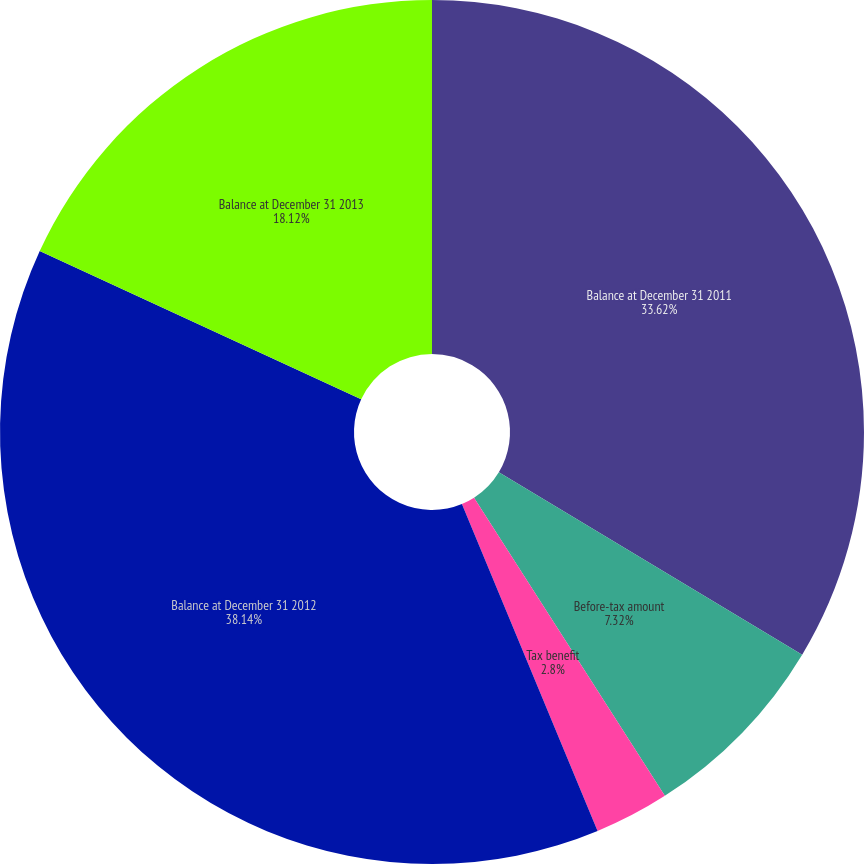Convert chart to OTSL. <chart><loc_0><loc_0><loc_500><loc_500><pie_chart><fcel>Balance at December 31 2011<fcel>Before-tax amount<fcel>Tax benefit<fcel>Balance at December 31 2012<fcel>Balance at December 31 2013<nl><fcel>33.62%<fcel>7.32%<fcel>2.8%<fcel>38.14%<fcel>18.12%<nl></chart> 